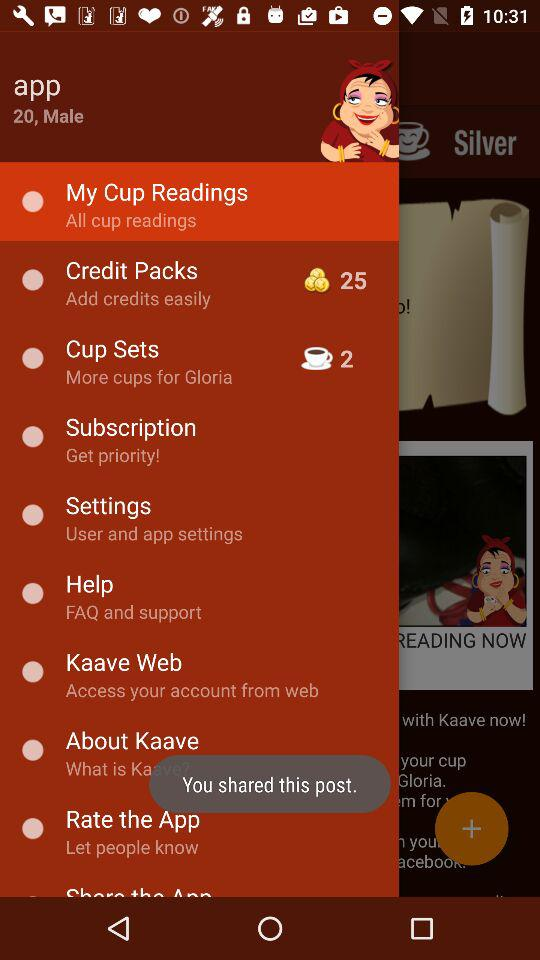What is the gender of the person? The gender of the person is male. 